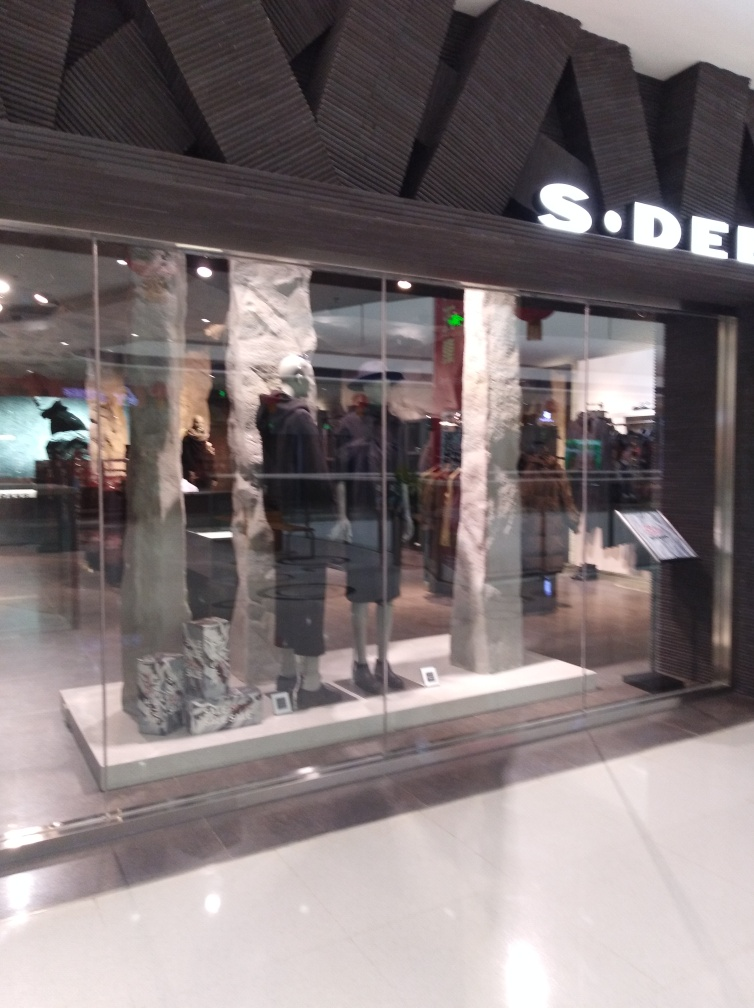Is the text on the storefront clear and visible?
 Yes 